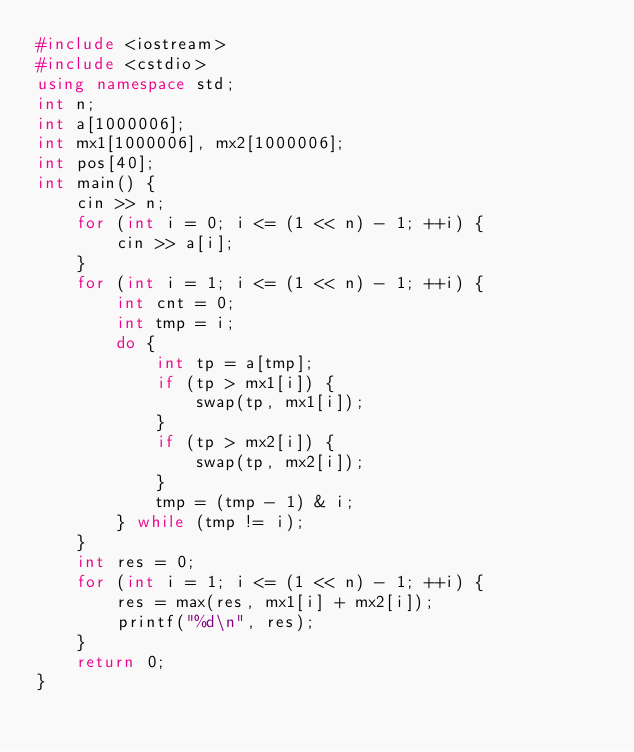Convert code to text. <code><loc_0><loc_0><loc_500><loc_500><_C++_>#include <iostream>
#include <cstdio>
using namespace std;
int n;
int a[1000006];
int mx1[1000006], mx2[1000006];
int pos[40];
int main() {
    cin >> n;
    for (int i = 0; i <= (1 << n) - 1; ++i) {
        cin >> a[i];
    }
    for (int i = 1; i <= (1 << n) - 1; ++i) {
        int cnt = 0;
        int tmp = i;
        do {
            int tp = a[tmp];
            if (tp > mx1[i]) {
                swap(tp, mx1[i]);
            }
            if (tp > mx2[i]) {
                swap(tp, mx2[i]);
            }
            tmp = (tmp - 1) & i;
        } while (tmp != i);
    }
    int res = 0;
    for (int i = 1; i <= (1 << n) - 1; ++i) {
        res = max(res, mx1[i] + mx2[i]);
        printf("%d\n", res);
    }
    return 0;
}</code> 